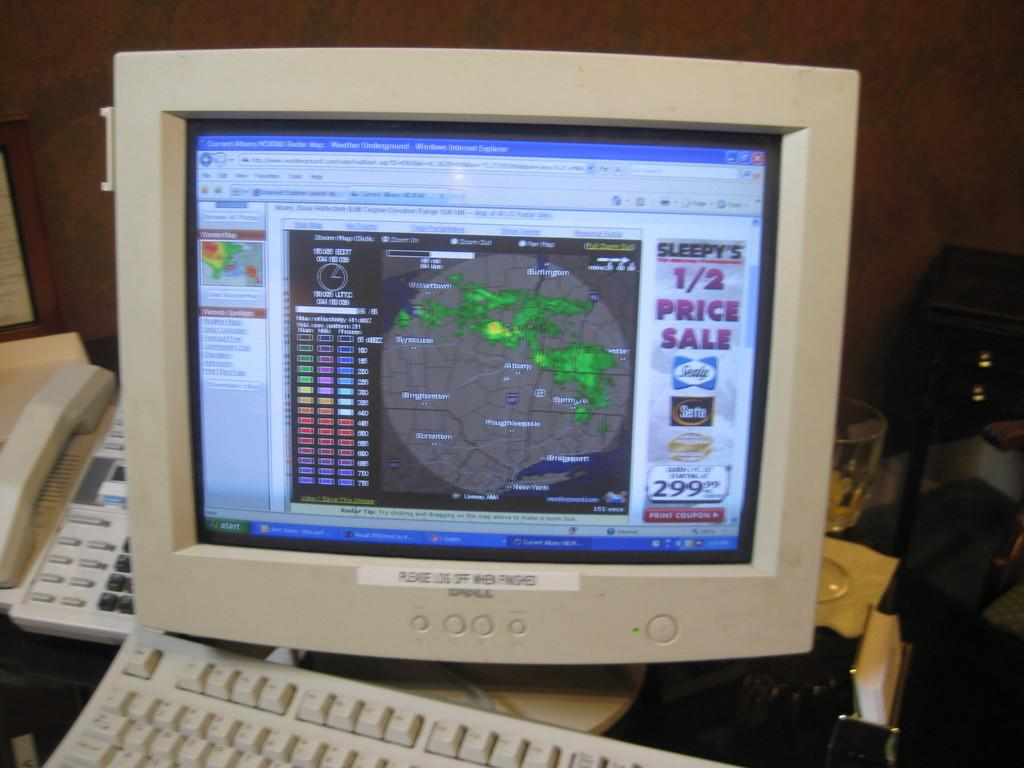Provide a one-sentence caption for the provided image. Sleepy's is having a 1/2 price sale, according to the computer monitor. 